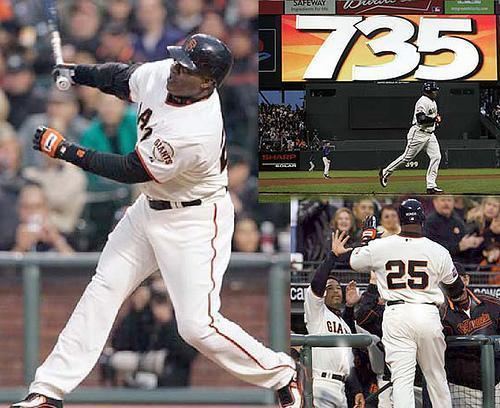How many people can you see?
Give a very brief answer. 5. 